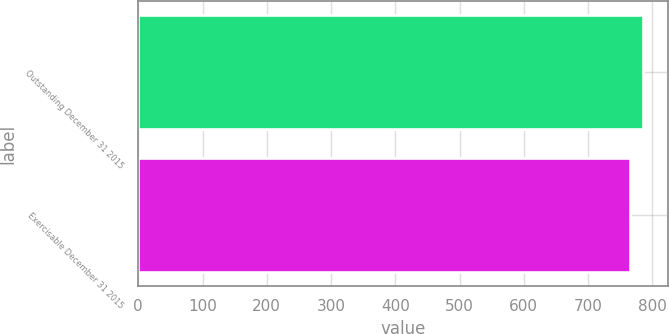Convert chart to OTSL. <chart><loc_0><loc_0><loc_500><loc_500><bar_chart><fcel>Outstanding December 31 2015<fcel>Exercisable December 31 2015<nl><fcel>785<fcel>765<nl></chart> 